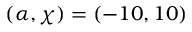Convert formula to latex. <formula><loc_0><loc_0><loc_500><loc_500>( \alpha , \chi ) = ( - 1 0 , 1 0 )</formula> 